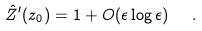<formula> <loc_0><loc_0><loc_500><loc_500>\hat { Z } ^ { \prime } ( z _ { 0 } ) = 1 + O ( \epsilon \log \epsilon ) \ \ .</formula> 